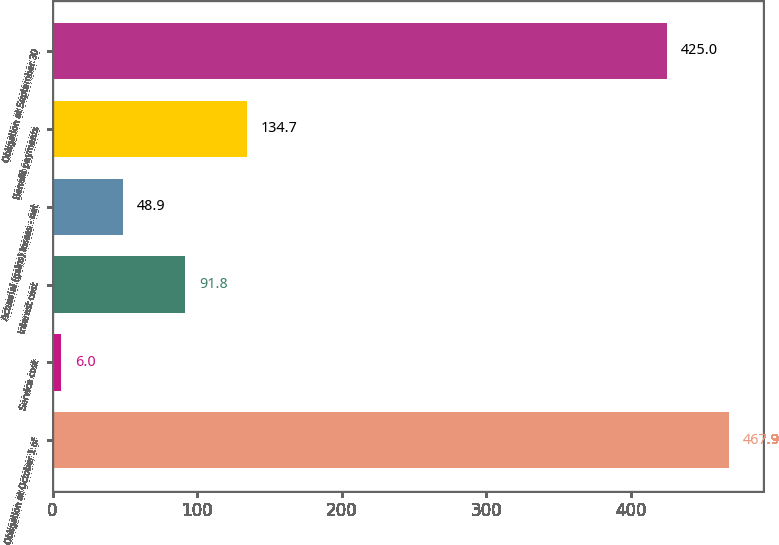<chart> <loc_0><loc_0><loc_500><loc_500><bar_chart><fcel>Obligation at October 1 of<fcel>Service cost<fcel>Interest cost<fcel>Actuarial (gains) losses - net<fcel>Benefit payments<fcel>Obligation at September 30<nl><fcel>467.9<fcel>6<fcel>91.8<fcel>48.9<fcel>134.7<fcel>425<nl></chart> 